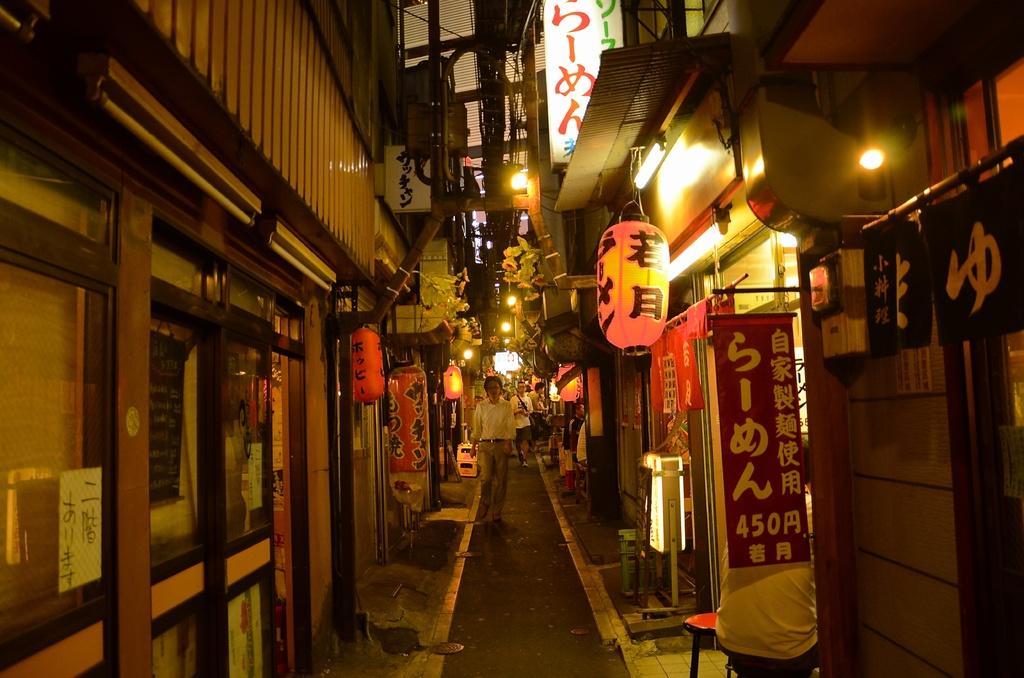Describe this image in one or two sentences. In this image I can see the street, few persons standing on the street, few lanterns and few buildings on both sides of the street. I can see few boards and few lights. 